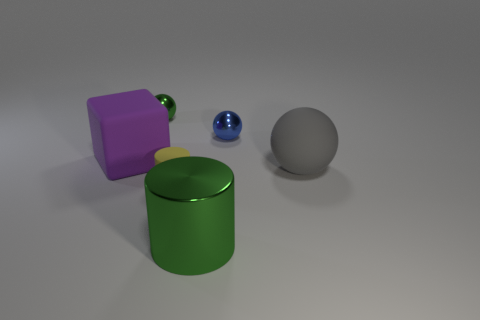Is there any other thing that is made of the same material as the blue ball?
Provide a succinct answer. Yes. Are there more large balls behind the gray matte sphere than balls?
Your answer should be very brief. No. There is a green object left of the green metal thing right of the tiny yellow cylinder; what number of tiny metal things are on the right side of it?
Provide a succinct answer. 1. Do the green object left of the yellow thing and the cylinder right of the small yellow object have the same size?
Keep it short and to the point. No. What material is the small sphere on the right side of the metallic object in front of the tiny blue object?
Provide a succinct answer. Metal. What number of objects are big things that are on the left side of the tiny green shiny sphere or small gray metallic cylinders?
Make the answer very short. 1. Is the number of purple rubber objects in front of the tiny yellow cylinder the same as the number of blue metallic things that are behind the green ball?
Keep it short and to the point. Yes. What is the material of the cube in front of the tiny green ball left of the green thing that is in front of the large cube?
Provide a succinct answer. Rubber. There is a sphere that is both to the right of the yellow matte cylinder and left of the gray thing; what size is it?
Keep it short and to the point. Small. Does the blue object have the same shape as the tiny green object?
Give a very brief answer. Yes. 